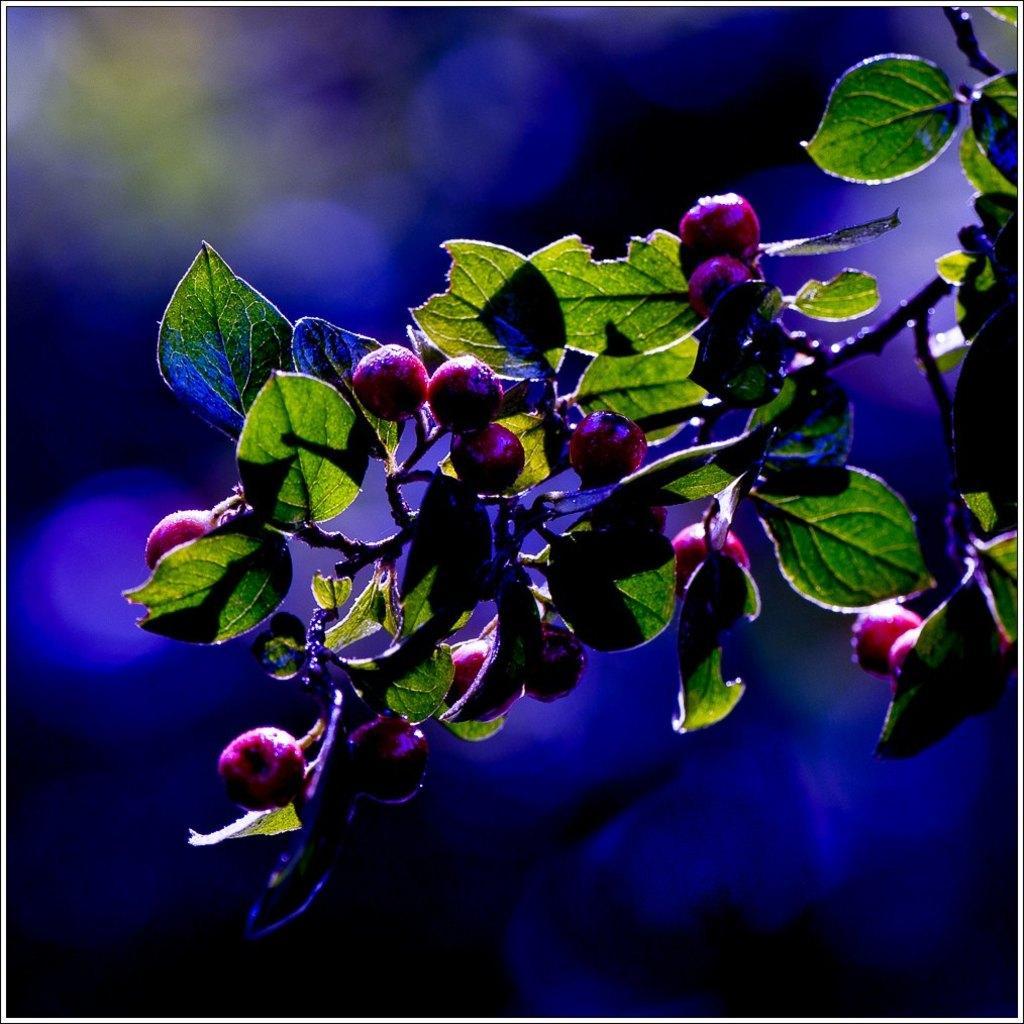Can you describe this image briefly? In this picture, we see a plant or a tree which has the fruits and these fruits are in red color. In the background, it is blue in color. This picture is blurred in the background. 